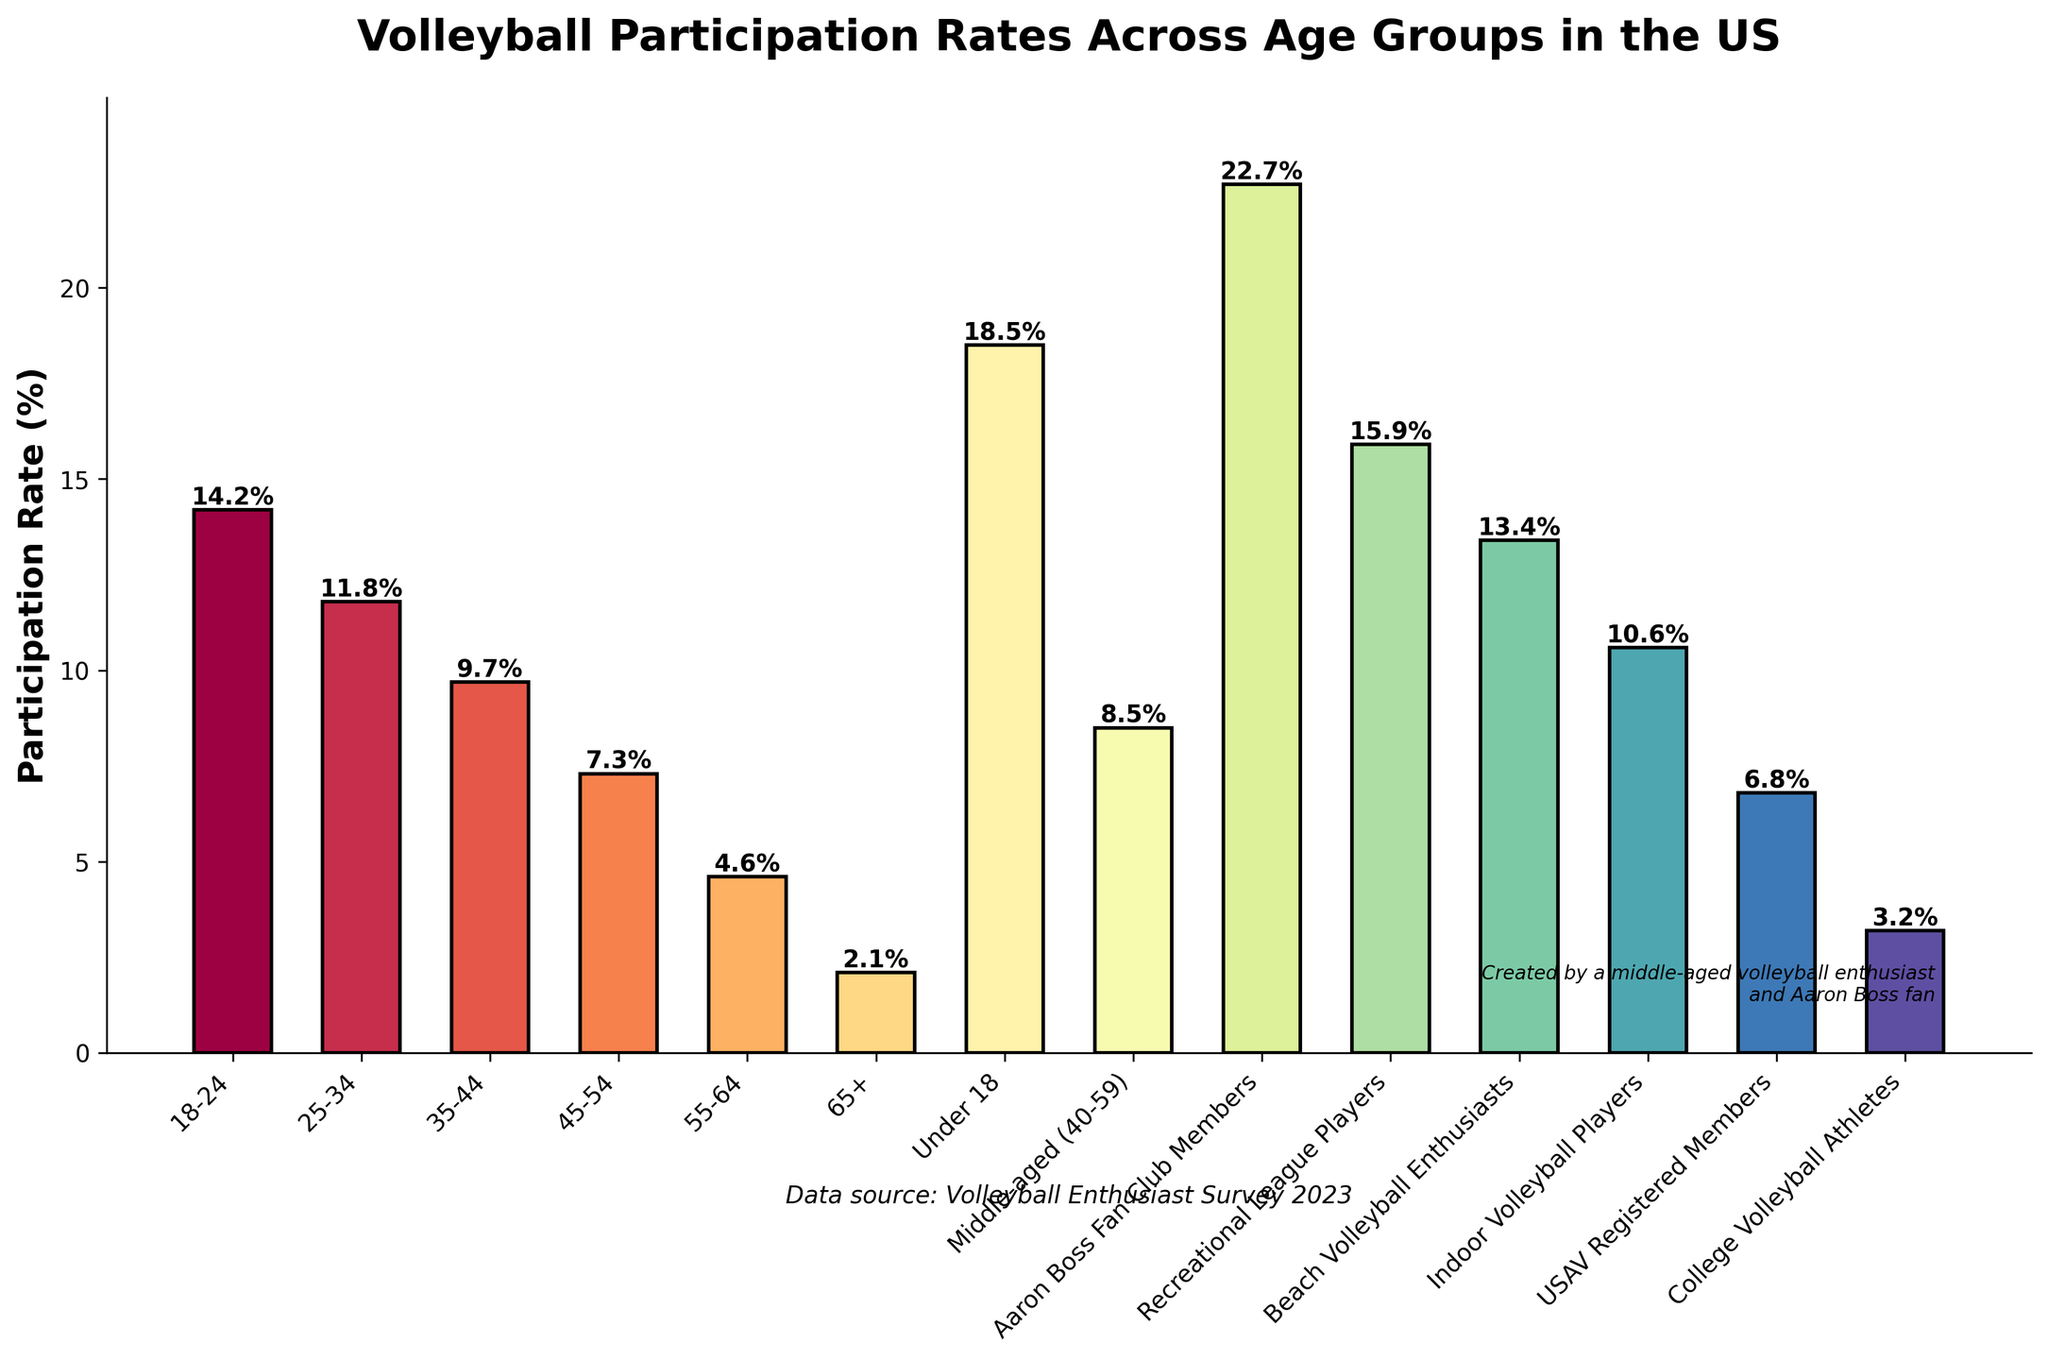Which age group has the highest volleyball participation rate? Identify the bar with the highest height and corresponding label, which is "Under 18" with a participation rate of 18.5%.
Answer: Under 18 Which group has a lower participation rate, USAV Registered Members or Recreational League Players? Compare the heights of the bars for USAV Registered Members (6.8%) and Recreational League Players (15.9%). The bar for USAV Registered Members is shorter.
Answer: USAV Registered Members What's the difference in participation rates between Beach Volleyball Enthusiasts and College Volleyball Athletes? Subtract the participation rate of College Volleyball Athletes (3.2%) from the rate of Beach Volleyball Enthusiasts (13.4%): 13.4% - 3.2% = 10.2%.
Answer: 10.2% What is the average participation rate for 'Middle-aged', '45-54', and '55-64' groups? Add all participation rates and divide by the number of rates: (8.5% + 7.3% + 4.6%) / 3 = 20.4% / 3 = 6.8%.
Answer: 6.8% Is the participation rate higher for Indoor Volleyball Players or Beach Volleyball Enthusiasts? Compare the heights of the bars for Indoor Volleyball Players (10.6%) and Beach Volleyball Enthusiasts (13.4%). The Beach Volleyball Enthusiasts group has a higher bar.
Answer: Beach Volleyball Enthusiasts Which of the following groups has the smallest participation rate: 65+, Indoor Volleyball Players, or Aaron Boss Fan Club Members? Compare the heights of the bars for 65+ (2.1%), Indoor Volleyball Players (10.6%), and Aaron Boss Fan Club Members (22.7%). The smallest bar is for the 65+ group.
Answer: 65+ What is the total participation rate for the groups: Under 18, 18-24, and Aaron Boss Fan Club Members? Sum the participation rates of the specified groups: 18.5% + 14.2% + 22.7% = 55.4%.
Answer: 55.4% Are there more college volleyball athletes or USAV registered members? Compare the heights of the bars for College Volleyball Athletes (3.2%) and USAV Registered Members (6.8%). There are more USAV Registered Members.
Answer: USAV Registered Members 